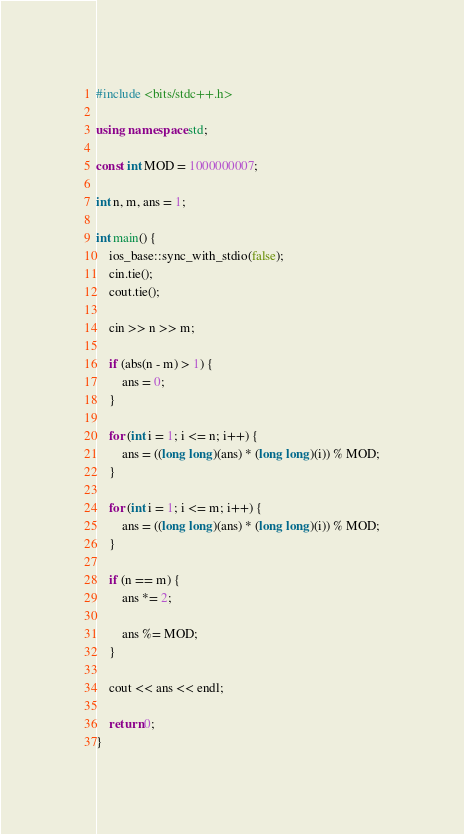<code> <loc_0><loc_0><loc_500><loc_500><_C++_>#include <bits/stdc++.h>

using namespace std;

const int MOD = 1000000007;

int n, m, ans = 1;

int main() {
    ios_base::sync_with_stdio(false);
    cin.tie();
    cout.tie();

    cin >> n >> m;

    if (abs(n - m) > 1) {
        ans = 0;
    }

    for (int i = 1; i <= n; i++) {
        ans = ((long long)(ans) * (long long)(i)) % MOD;
    }

    for (int i = 1; i <= m; i++) {
        ans = ((long long)(ans) * (long long)(i)) % MOD;
    }

    if (n == m) {
        ans *= 2;

        ans %= MOD;
    }

    cout << ans << endl;

    return 0;
}
</code> 